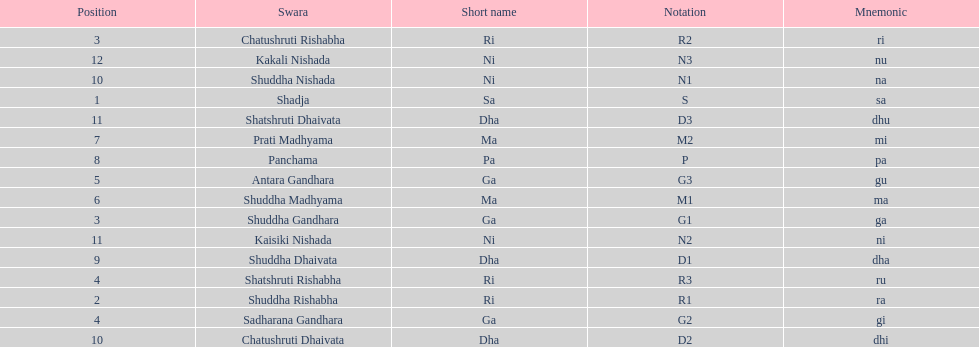Which swara follows immediately after antara gandhara? Shuddha Madhyama. 